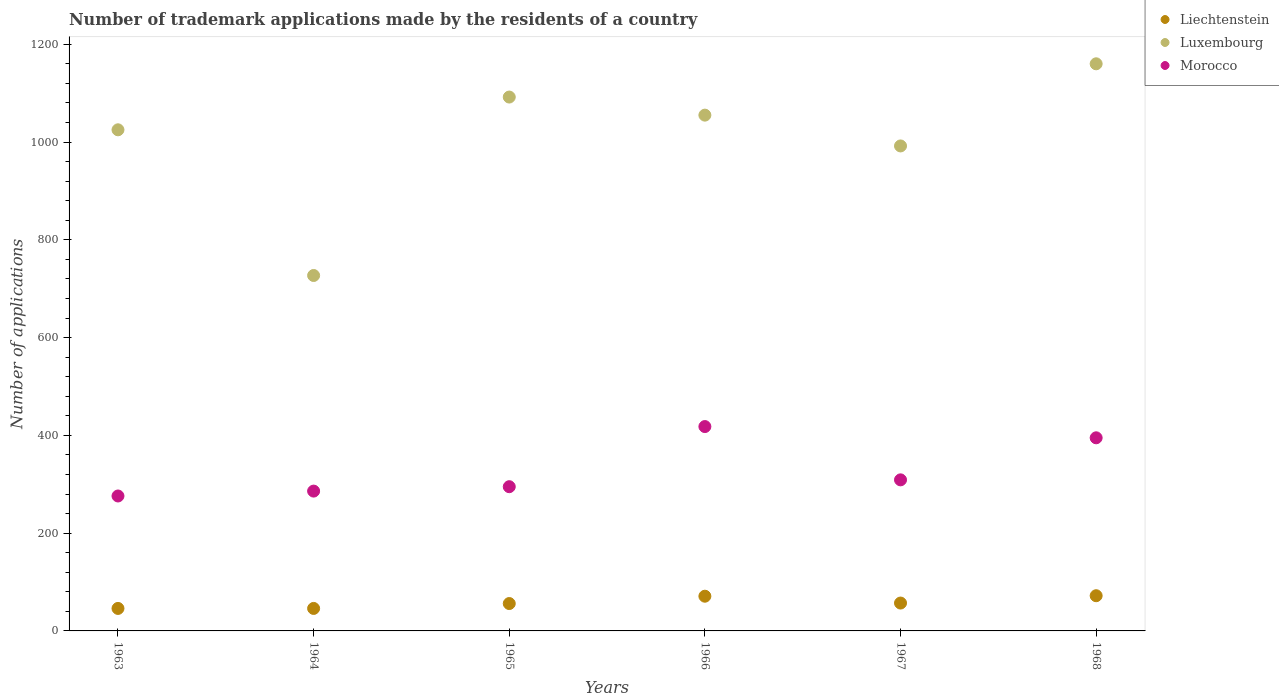How many different coloured dotlines are there?
Make the answer very short. 3. Is the number of dotlines equal to the number of legend labels?
Ensure brevity in your answer.  Yes. What is the number of trademark applications made by the residents in Luxembourg in 1965?
Your answer should be very brief. 1092. Across all years, what is the maximum number of trademark applications made by the residents in Luxembourg?
Make the answer very short. 1160. Across all years, what is the minimum number of trademark applications made by the residents in Luxembourg?
Your response must be concise. 727. In which year was the number of trademark applications made by the residents in Morocco maximum?
Give a very brief answer. 1966. In which year was the number of trademark applications made by the residents in Luxembourg minimum?
Ensure brevity in your answer.  1964. What is the total number of trademark applications made by the residents in Morocco in the graph?
Your response must be concise. 1979. What is the difference between the number of trademark applications made by the residents in Luxembourg in 1963 and that in 1965?
Ensure brevity in your answer.  -67. What is the difference between the number of trademark applications made by the residents in Liechtenstein in 1968 and the number of trademark applications made by the residents in Morocco in 1965?
Make the answer very short. -223. What is the average number of trademark applications made by the residents in Luxembourg per year?
Provide a succinct answer. 1008.5. In the year 1966, what is the difference between the number of trademark applications made by the residents in Morocco and number of trademark applications made by the residents in Liechtenstein?
Offer a terse response. 347. In how many years, is the number of trademark applications made by the residents in Liechtenstein greater than 520?
Your response must be concise. 0. What is the ratio of the number of trademark applications made by the residents in Liechtenstein in 1967 to that in 1968?
Provide a succinct answer. 0.79. Is the number of trademark applications made by the residents in Morocco in 1964 less than that in 1965?
Your answer should be compact. Yes. Is the difference between the number of trademark applications made by the residents in Morocco in 1963 and 1964 greater than the difference between the number of trademark applications made by the residents in Liechtenstein in 1963 and 1964?
Provide a succinct answer. No. What is the difference between the highest and the second highest number of trademark applications made by the residents in Morocco?
Keep it short and to the point. 23. What is the difference between the highest and the lowest number of trademark applications made by the residents in Luxembourg?
Give a very brief answer. 433. In how many years, is the number of trademark applications made by the residents in Luxembourg greater than the average number of trademark applications made by the residents in Luxembourg taken over all years?
Provide a succinct answer. 4. Is the sum of the number of trademark applications made by the residents in Luxembourg in 1966 and 1968 greater than the maximum number of trademark applications made by the residents in Liechtenstein across all years?
Ensure brevity in your answer.  Yes. Does the number of trademark applications made by the residents in Luxembourg monotonically increase over the years?
Give a very brief answer. No. Is the number of trademark applications made by the residents in Luxembourg strictly greater than the number of trademark applications made by the residents in Morocco over the years?
Your response must be concise. Yes. Is the number of trademark applications made by the residents in Luxembourg strictly less than the number of trademark applications made by the residents in Morocco over the years?
Provide a succinct answer. No. How many years are there in the graph?
Make the answer very short. 6. Does the graph contain grids?
Provide a short and direct response. No. How are the legend labels stacked?
Your answer should be very brief. Vertical. What is the title of the graph?
Give a very brief answer. Number of trademark applications made by the residents of a country. What is the label or title of the X-axis?
Your answer should be compact. Years. What is the label or title of the Y-axis?
Give a very brief answer. Number of applications. What is the Number of applications in Liechtenstein in 1963?
Ensure brevity in your answer.  46. What is the Number of applications of Luxembourg in 1963?
Offer a very short reply. 1025. What is the Number of applications in Morocco in 1963?
Give a very brief answer. 276. What is the Number of applications of Luxembourg in 1964?
Offer a terse response. 727. What is the Number of applications in Morocco in 1964?
Offer a terse response. 286. What is the Number of applications of Luxembourg in 1965?
Your response must be concise. 1092. What is the Number of applications in Morocco in 1965?
Provide a short and direct response. 295. What is the Number of applications in Luxembourg in 1966?
Your answer should be very brief. 1055. What is the Number of applications in Morocco in 1966?
Make the answer very short. 418. What is the Number of applications of Luxembourg in 1967?
Keep it short and to the point. 992. What is the Number of applications of Morocco in 1967?
Ensure brevity in your answer.  309. What is the Number of applications of Liechtenstein in 1968?
Offer a very short reply. 72. What is the Number of applications of Luxembourg in 1968?
Your answer should be compact. 1160. What is the Number of applications of Morocco in 1968?
Offer a very short reply. 395. Across all years, what is the maximum Number of applications in Liechtenstein?
Your answer should be very brief. 72. Across all years, what is the maximum Number of applications in Luxembourg?
Offer a very short reply. 1160. Across all years, what is the maximum Number of applications in Morocco?
Give a very brief answer. 418. Across all years, what is the minimum Number of applications of Liechtenstein?
Provide a succinct answer. 46. Across all years, what is the minimum Number of applications in Luxembourg?
Provide a succinct answer. 727. Across all years, what is the minimum Number of applications in Morocco?
Ensure brevity in your answer.  276. What is the total Number of applications of Liechtenstein in the graph?
Offer a terse response. 348. What is the total Number of applications in Luxembourg in the graph?
Ensure brevity in your answer.  6051. What is the total Number of applications of Morocco in the graph?
Offer a very short reply. 1979. What is the difference between the Number of applications in Liechtenstein in 1963 and that in 1964?
Keep it short and to the point. 0. What is the difference between the Number of applications of Luxembourg in 1963 and that in 1964?
Keep it short and to the point. 298. What is the difference between the Number of applications of Liechtenstein in 1963 and that in 1965?
Give a very brief answer. -10. What is the difference between the Number of applications of Luxembourg in 1963 and that in 1965?
Give a very brief answer. -67. What is the difference between the Number of applications of Morocco in 1963 and that in 1966?
Offer a terse response. -142. What is the difference between the Number of applications in Liechtenstein in 1963 and that in 1967?
Your answer should be very brief. -11. What is the difference between the Number of applications of Luxembourg in 1963 and that in 1967?
Give a very brief answer. 33. What is the difference between the Number of applications in Morocco in 1963 and that in 1967?
Your response must be concise. -33. What is the difference between the Number of applications of Luxembourg in 1963 and that in 1968?
Keep it short and to the point. -135. What is the difference between the Number of applications of Morocco in 1963 and that in 1968?
Make the answer very short. -119. What is the difference between the Number of applications of Luxembourg in 1964 and that in 1965?
Make the answer very short. -365. What is the difference between the Number of applications in Morocco in 1964 and that in 1965?
Offer a very short reply. -9. What is the difference between the Number of applications of Luxembourg in 1964 and that in 1966?
Provide a succinct answer. -328. What is the difference between the Number of applications in Morocco in 1964 and that in 1966?
Keep it short and to the point. -132. What is the difference between the Number of applications in Luxembourg in 1964 and that in 1967?
Give a very brief answer. -265. What is the difference between the Number of applications in Luxembourg in 1964 and that in 1968?
Offer a very short reply. -433. What is the difference between the Number of applications of Morocco in 1964 and that in 1968?
Offer a very short reply. -109. What is the difference between the Number of applications of Morocco in 1965 and that in 1966?
Your response must be concise. -123. What is the difference between the Number of applications of Morocco in 1965 and that in 1967?
Keep it short and to the point. -14. What is the difference between the Number of applications in Luxembourg in 1965 and that in 1968?
Provide a succinct answer. -68. What is the difference between the Number of applications of Morocco in 1965 and that in 1968?
Provide a succinct answer. -100. What is the difference between the Number of applications of Luxembourg in 1966 and that in 1967?
Give a very brief answer. 63. What is the difference between the Number of applications in Morocco in 1966 and that in 1967?
Your answer should be compact. 109. What is the difference between the Number of applications in Luxembourg in 1966 and that in 1968?
Offer a terse response. -105. What is the difference between the Number of applications in Morocco in 1966 and that in 1968?
Provide a short and direct response. 23. What is the difference between the Number of applications in Liechtenstein in 1967 and that in 1968?
Your answer should be compact. -15. What is the difference between the Number of applications of Luxembourg in 1967 and that in 1968?
Make the answer very short. -168. What is the difference between the Number of applications of Morocco in 1967 and that in 1968?
Your answer should be compact. -86. What is the difference between the Number of applications of Liechtenstein in 1963 and the Number of applications of Luxembourg in 1964?
Make the answer very short. -681. What is the difference between the Number of applications of Liechtenstein in 1963 and the Number of applications of Morocco in 1964?
Ensure brevity in your answer.  -240. What is the difference between the Number of applications of Luxembourg in 1963 and the Number of applications of Morocco in 1964?
Offer a terse response. 739. What is the difference between the Number of applications in Liechtenstein in 1963 and the Number of applications in Luxembourg in 1965?
Offer a terse response. -1046. What is the difference between the Number of applications of Liechtenstein in 1963 and the Number of applications of Morocco in 1965?
Give a very brief answer. -249. What is the difference between the Number of applications of Luxembourg in 1963 and the Number of applications of Morocco in 1965?
Offer a terse response. 730. What is the difference between the Number of applications in Liechtenstein in 1963 and the Number of applications in Luxembourg in 1966?
Your answer should be compact. -1009. What is the difference between the Number of applications of Liechtenstein in 1963 and the Number of applications of Morocco in 1966?
Ensure brevity in your answer.  -372. What is the difference between the Number of applications of Luxembourg in 1963 and the Number of applications of Morocco in 1966?
Your answer should be very brief. 607. What is the difference between the Number of applications in Liechtenstein in 1963 and the Number of applications in Luxembourg in 1967?
Give a very brief answer. -946. What is the difference between the Number of applications of Liechtenstein in 1963 and the Number of applications of Morocco in 1967?
Your answer should be very brief. -263. What is the difference between the Number of applications of Luxembourg in 1963 and the Number of applications of Morocco in 1967?
Your response must be concise. 716. What is the difference between the Number of applications of Liechtenstein in 1963 and the Number of applications of Luxembourg in 1968?
Give a very brief answer. -1114. What is the difference between the Number of applications in Liechtenstein in 1963 and the Number of applications in Morocco in 1968?
Offer a very short reply. -349. What is the difference between the Number of applications of Luxembourg in 1963 and the Number of applications of Morocco in 1968?
Offer a terse response. 630. What is the difference between the Number of applications of Liechtenstein in 1964 and the Number of applications of Luxembourg in 1965?
Your response must be concise. -1046. What is the difference between the Number of applications of Liechtenstein in 1964 and the Number of applications of Morocco in 1965?
Provide a succinct answer. -249. What is the difference between the Number of applications of Luxembourg in 1964 and the Number of applications of Morocco in 1965?
Your response must be concise. 432. What is the difference between the Number of applications of Liechtenstein in 1964 and the Number of applications of Luxembourg in 1966?
Keep it short and to the point. -1009. What is the difference between the Number of applications in Liechtenstein in 1964 and the Number of applications in Morocco in 1966?
Provide a succinct answer. -372. What is the difference between the Number of applications in Luxembourg in 1964 and the Number of applications in Morocco in 1966?
Your answer should be very brief. 309. What is the difference between the Number of applications of Liechtenstein in 1964 and the Number of applications of Luxembourg in 1967?
Give a very brief answer. -946. What is the difference between the Number of applications in Liechtenstein in 1964 and the Number of applications in Morocco in 1967?
Your response must be concise. -263. What is the difference between the Number of applications in Luxembourg in 1964 and the Number of applications in Morocco in 1967?
Make the answer very short. 418. What is the difference between the Number of applications in Liechtenstein in 1964 and the Number of applications in Luxembourg in 1968?
Your answer should be very brief. -1114. What is the difference between the Number of applications in Liechtenstein in 1964 and the Number of applications in Morocco in 1968?
Provide a succinct answer. -349. What is the difference between the Number of applications in Luxembourg in 1964 and the Number of applications in Morocco in 1968?
Your response must be concise. 332. What is the difference between the Number of applications of Liechtenstein in 1965 and the Number of applications of Luxembourg in 1966?
Make the answer very short. -999. What is the difference between the Number of applications in Liechtenstein in 1965 and the Number of applications in Morocco in 1966?
Provide a short and direct response. -362. What is the difference between the Number of applications of Luxembourg in 1965 and the Number of applications of Morocco in 1966?
Ensure brevity in your answer.  674. What is the difference between the Number of applications of Liechtenstein in 1965 and the Number of applications of Luxembourg in 1967?
Your answer should be very brief. -936. What is the difference between the Number of applications in Liechtenstein in 1965 and the Number of applications in Morocco in 1967?
Your answer should be compact. -253. What is the difference between the Number of applications in Luxembourg in 1965 and the Number of applications in Morocco in 1967?
Your answer should be very brief. 783. What is the difference between the Number of applications in Liechtenstein in 1965 and the Number of applications in Luxembourg in 1968?
Your answer should be very brief. -1104. What is the difference between the Number of applications in Liechtenstein in 1965 and the Number of applications in Morocco in 1968?
Your response must be concise. -339. What is the difference between the Number of applications in Luxembourg in 1965 and the Number of applications in Morocco in 1968?
Provide a succinct answer. 697. What is the difference between the Number of applications of Liechtenstein in 1966 and the Number of applications of Luxembourg in 1967?
Keep it short and to the point. -921. What is the difference between the Number of applications of Liechtenstein in 1966 and the Number of applications of Morocco in 1967?
Offer a terse response. -238. What is the difference between the Number of applications in Luxembourg in 1966 and the Number of applications in Morocco in 1967?
Make the answer very short. 746. What is the difference between the Number of applications of Liechtenstein in 1966 and the Number of applications of Luxembourg in 1968?
Your response must be concise. -1089. What is the difference between the Number of applications in Liechtenstein in 1966 and the Number of applications in Morocco in 1968?
Make the answer very short. -324. What is the difference between the Number of applications in Luxembourg in 1966 and the Number of applications in Morocco in 1968?
Offer a very short reply. 660. What is the difference between the Number of applications in Liechtenstein in 1967 and the Number of applications in Luxembourg in 1968?
Offer a very short reply. -1103. What is the difference between the Number of applications of Liechtenstein in 1967 and the Number of applications of Morocco in 1968?
Your answer should be very brief. -338. What is the difference between the Number of applications of Luxembourg in 1967 and the Number of applications of Morocco in 1968?
Ensure brevity in your answer.  597. What is the average Number of applications of Liechtenstein per year?
Offer a terse response. 58. What is the average Number of applications in Luxembourg per year?
Your answer should be compact. 1008.5. What is the average Number of applications in Morocco per year?
Give a very brief answer. 329.83. In the year 1963, what is the difference between the Number of applications in Liechtenstein and Number of applications in Luxembourg?
Give a very brief answer. -979. In the year 1963, what is the difference between the Number of applications in Liechtenstein and Number of applications in Morocco?
Provide a succinct answer. -230. In the year 1963, what is the difference between the Number of applications in Luxembourg and Number of applications in Morocco?
Keep it short and to the point. 749. In the year 1964, what is the difference between the Number of applications of Liechtenstein and Number of applications of Luxembourg?
Offer a very short reply. -681. In the year 1964, what is the difference between the Number of applications of Liechtenstein and Number of applications of Morocco?
Offer a terse response. -240. In the year 1964, what is the difference between the Number of applications of Luxembourg and Number of applications of Morocco?
Offer a terse response. 441. In the year 1965, what is the difference between the Number of applications in Liechtenstein and Number of applications in Luxembourg?
Make the answer very short. -1036. In the year 1965, what is the difference between the Number of applications of Liechtenstein and Number of applications of Morocco?
Provide a succinct answer. -239. In the year 1965, what is the difference between the Number of applications in Luxembourg and Number of applications in Morocco?
Offer a very short reply. 797. In the year 1966, what is the difference between the Number of applications in Liechtenstein and Number of applications in Luxembourg?
Offer a very short reply. -984. In the year 1966, what is the difference between the Number of applications of Liechtenstein and Number of applications of Morocco?
Your response must be concise. -347. In the year 1966, what is the difference between the Number of applications in Luxembourg and Number of applications in Morocco?
Offer a terse response. 637. In the year 1967, what is the difference between the Number of applications in Liechtenstein and Number of applications in Luxembourg?
Make the answer very short. -935. In the year 1967, what is the difference between the Number of applications of Liechtenstein and Number of applications of Morocco?
Offer a terse response. -252. In the year 1967, what is the difference between the Number of applications in Luxembourg and Number of applications in Morocco?
Give a very brief answer. 683. In the year 1968, what is the difference between the Number of applications of Liechtenstein and Number of applications of Luxembourg?
Keep it short and to the point. -1088. In the year 1968, what is the difference between the Number of applications in Liechtenstein and Number of applications in Morocco?
Offer a very short reply. -323. In the year 1968, what is the difference between the Number of applications in Luxembourg and Number of applications in Morocco?
Offer a terse response. 765. What is the ratio of the Number of applications of Luxembourg in 1963 to that in 1964?
Ensure brevity in your answer.  1.41. What is the ratio of the Number of applications of Morocco in 1963 to that in 1964?
Offer a very short reply. 0.96. What is the ratio of the Number of applications of Liechtenstein in 1963 to that in 1965?
Your answer should be very brief. 0.82. What is the ratio of the Number of applications in Luxembourg in 1963 to that in 1965?
Ensure brevity in your answer.  0.94. What is the ratio of the Number of applications in Morocco in 1963 to that in 1965?
Ensure brevity in your answer.  0.94. What is the ratio of the Number of applications in Liechtenstein in 1963 to that in 1966?
Your answer should be very brief. 0.65. What is the ratio of the Number of applications in Luxembourg in 1963 to that in 1966?
Ensure brevity in your answer.  0.97. What is the ratio of the Number of applications of Morocco in 1963 to that in 1966?
Offer a terse response. 0.66. What is the ratio of the Number of applications in Liechtenstein in 1963 to that in 1967?
Your answer should be very brief. 0.81. What is the ratio of the Number of applications in Luxembourg in 1963 to that in 1967?
Offer a terse response. 1.03. What is the ratio of the Number of applications in Morocco in 1963 to that in 1967?
Your answer should be compact. 0.89. What is the ratio of the Number of applications of Liechtenstein in 1963 to that in 1968?
Give a very brief answer. 0.64. What is the ratio of the Number of applications of Luxembourg in 1963 to that in 1968?
Your response must be concise. 0.88. What is the ratio of the Number of applications in Morocco in 1963 to that in 1968?
Provide a succinct answer. 0.7. What is the ratio of the Number of applications of Liechtenstein in 1964 to that in 1965?
Provide a short and direct response. 0.82. What is the ratio of the Number of applications of Luxembourg in 1964 to that in 1965?
Your answer should be very brief. 0.67. What is the ratio of the Number of applications in Morocco in 1964 to that in 1965?
Make the answer very short. 0.97. What is the ratio of the Number of applications of Liechtenstein in 1964 to that in 1966?
Offer a terse response. 0.65. What is the ratio of the Number of applications of Luxembourg in 1964 to that in 1966?
Make the answer very short. 0.69. What is the ratio of the Number of applications in Morocco in 1964 to that in 1966?
Make the answer very short. 0.68. What is the ratio of the Number of applications in Liechtenstein in 1964 to that in 1967?
Provide a short and direct response. 0.81. What is the ratio of the Number of applications of Luxembourg in 1964 to that in 1967?
Make the answer very short. 0.73. What is the ratio of the Number of applications of Morocco in 1964 to that in 1967?
Your answer should be very brief. 0.93. What is the ratio of the Number of applications in Liechtenstein in 1964 to that in 1968?
Your answer should be very brief. 0.64. What is the ratio of the Number of applications in Luxembourg in 1964 to that in 1968?
Keep it short and to the point. 0.63. What is the ratio of the Number of applications of Morocco in 1964 to that in 1968?
Keep it short and to the point. 0.72. What is the ratio of the Number of applications in Liechtenstein in 1965 to that in 1966?
Give a very brief answer. 0.79. What is the ratio of the Number of applications of Luxembourg in 1965 to that in 1966?
Make the answer very short. 1.04. What is the ratio of the Number of applications in Morocco in 1965 to that in 1966?
Offer a very short reply. 0.71. What is the ratio of the Number of applications of Liechtenstein in 1965 to that in 1967?
Keep it short and to the point. 0.98. What is the ratio of the Number of applications in Luxembourg in 1965 to that in 1967?
Your answer should be compact. 1.1. What is the ratio of the Number of applications of Morocco in 1965 to that in 1967?
Offer a terse response. 0.95. What is the ratio of the Number of applications in Liechtenstein in 1965 to that in 1968?
Provide a succinct answer. 0.78. What is the ratio of the Number of applications in Luxembourg in 1965 to that in 1968?
Your answer should be very brief. 0.94. What is the ratio of the Number of applications of Morocco in 1965 to that in 1968?
Make the answer very short. 0.75. What is the ratio of the Number of applications in Liechtenstein in 1966 to that in 1967?
Make the answer very short. 1.25. What is the ratio of the Number of applications in Luxembourg in 1966 to that in 1967?
Your response must be concise. 1.06. What is the ratio of the Number of applications in Morocco in 1966 to that in 1967?
Provide a short and direct response. 1.35. What is the ratio of the Number of applications of Liechtenstein in 1966 to that in 1968?
Make the answer very short. 0.99. What is the ratio of the Number of applications in Luxembourg in 1966 to that in 1968?
Keep it short and to the point. 0.91. What is the ratio of the Number of applications of Morocco in 1966 to that in 1968?
Provide a short and direct response. 1.06. What is the ratio of the Number of applications of Liechtenstein in 1967 to that in 1968?
Your answer should be compact. 0.79. What is the ratio of the Number of applications in Luxembourg in 1967 to that in 1968?
Offer a terse response. 0.86. What is the ratio of the Number of applications of Morocco in 1967 to that in 1968?
Provide a short and direct response. 0.78. What is the difference between the highest and the second highest Number of applications in Liechtenstein?
Provide a short and direct response. 1. What is the difference between the highest and the second highest Number of applications in Morocco?
Give a very brief answer. 23. What is the difference between the highest and the lowest Number of applications of Liechtenstein?
Your answer should be compact. 26. What is the difference between the highest and the lowest Number of applications in Luxembourg?
Provide a short and direct response. 433. What is the difference between the highest and the lowest Number of applications of Morocco?
Make the answer very short. 142. 